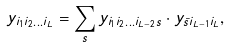<formula> <loc_0><loc_0><loc_500><loc_500>y _ { i _ { 1 } i _ { 2 } \dots i _ { L } } = \sum _ { s } y _ { i _ { 1 } i _ { 2 } \dots i _ { L - 2 } s } \cdot y _ { \bar { s } i _ { L - 1 } i _ { L } } ,</formula> 